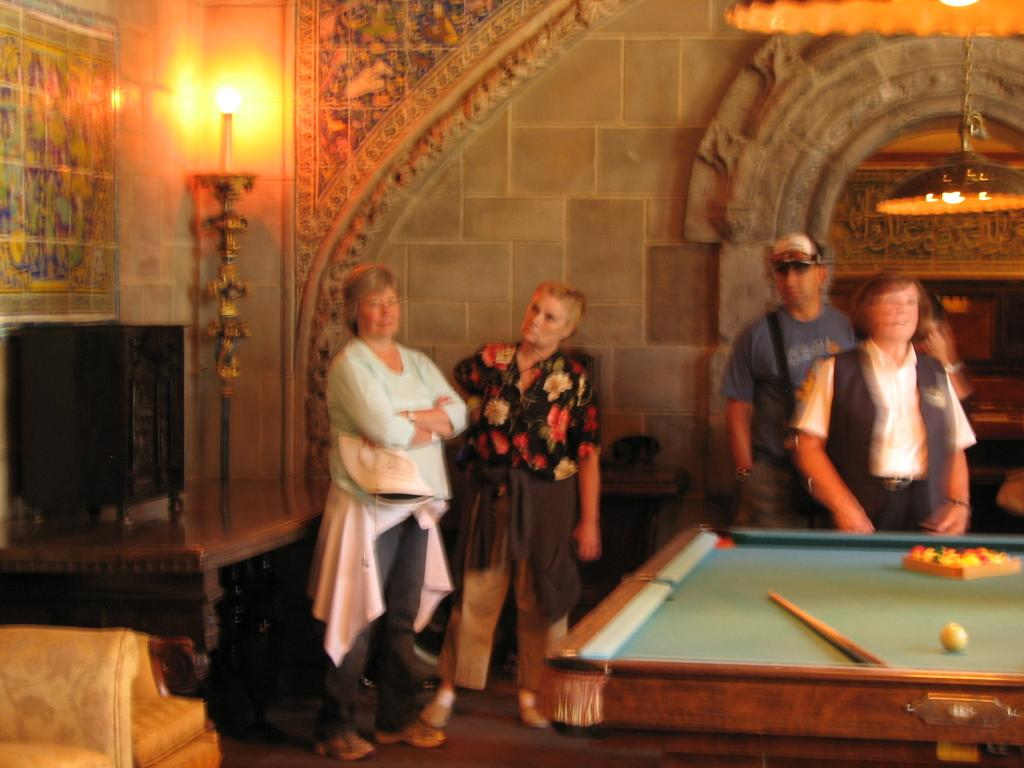What game is being played in the image? There is a pool board on the right side of the image, suggesting that the game being played is pool. How many people are involved in the game? Four people are standing behind the pool board, indicating that there are four players. Where is the candle located in the image? The candle is in the left corner of the image. What color is the paint on the pool board? There is no paint mentioned or visible on the pool board in the image. 